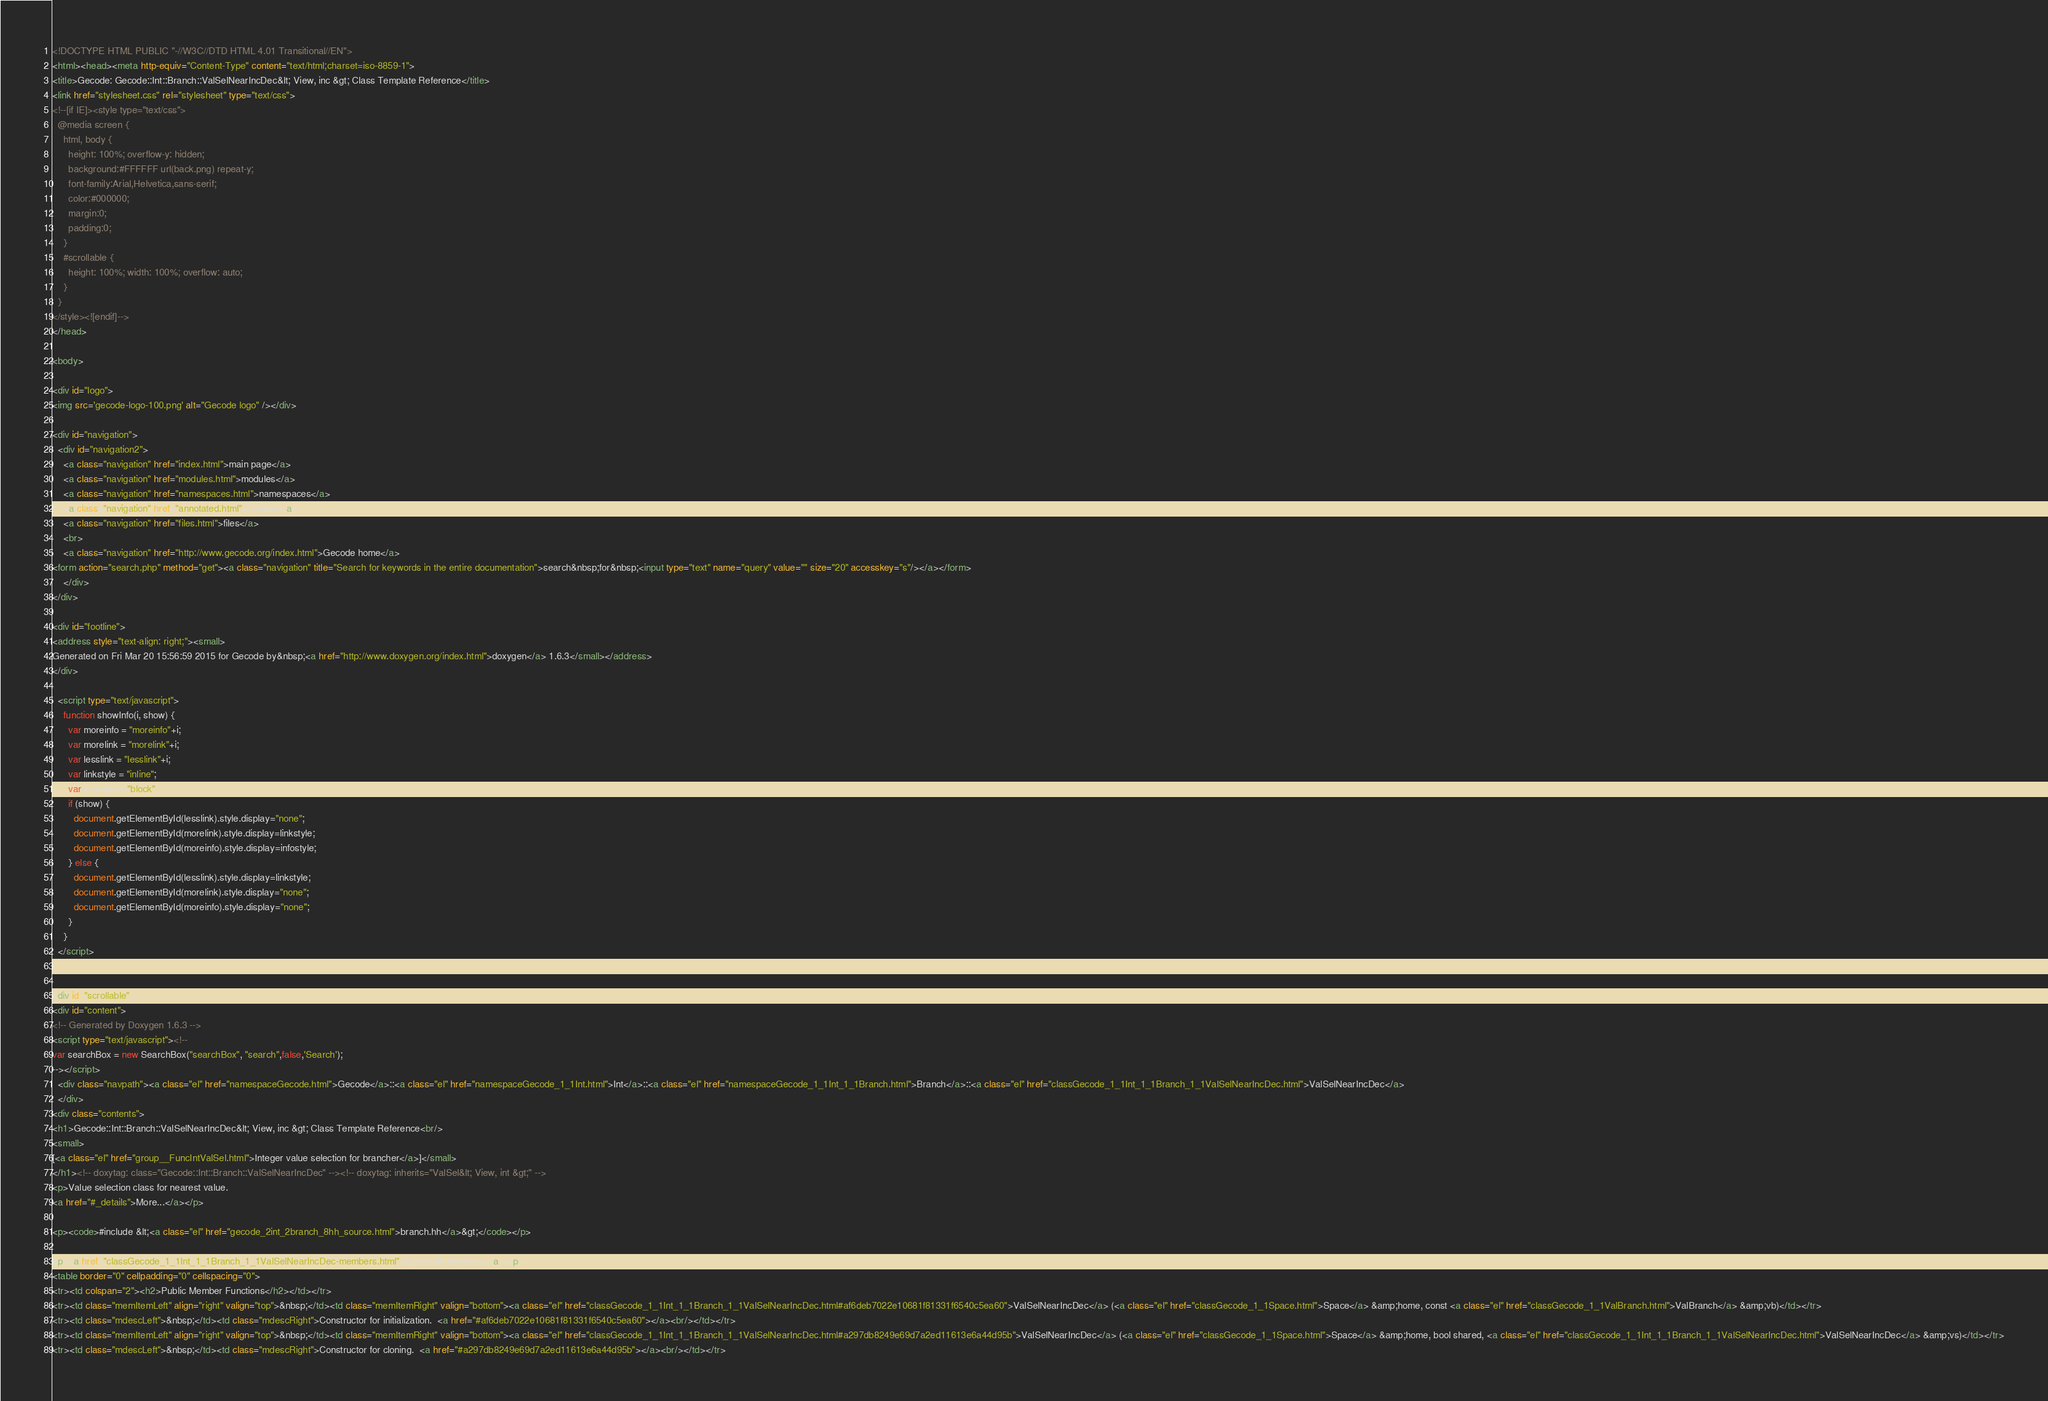Convert code to text. <code><loc_0><loc_0><loc_500><loc_500><_HTML_><!DOCTYPE HTML PUBLIC "-//W3C//DTD HTML 4.01 Transitional//EN">
<html><head><meta http-equiv="Content-Type" content="text/html;charset=iso-8859-1">
<title>Gecode: Gecode::Int::Branch::ValSelNearIncDec&lt; View, inc &gt; Class Template Reference</title>
<link href="stylesheet.css" rel="stylesheet" type="text/css">
<!--[if IE]><style type="text/css">
  @media screen {
    html, body {
      height: 100%; overflow-y: hidden;
      background:#FFFFFF url(back.png) repeat-y;
      font-family:Arial,Helvetica,sans-serif;
      color:#000000;
      margin:0;
      padding:0;
    }
    #scrollable {
      height: 100%; width: 100%; overflow: auto;
    }
  }
</style><![endif]-->
</head>

<body>

<div id="logo">
<img src='gecode-logo-100.png' alt="Gecode logo" /></div>

<div id="navigation">
  <div id="navigation2">
    <a class="navigation" href="index.html">main page</a>
    <a class="navigation" href="modules.html">modules</a>
    <a class="navigation" href="namespaces.html">namespaces</a>
    <a class="navigation" href="annotated.html">classes</a>
    <a class="navigation" href="files.html">files</a>
    <br>
    <a class="navigation" href="http://www.gecode.org/index.html">Gecode home</a>
<form action="search.php" method="get"><a class="navigation" title="Search for keywords in the entire documentation">search&nbsp;for&nbsp;<input type="text" name="query" value="" size="20" accesskey="s"/></a></form>
    </div>
</div>

<div id="footline">
<address style="text-align: right;"><small>
Generated on Fri Mar 20 15:56:59 2015 for Gecode by&nbsp;<a href="http://www.doxygen.org/index.html">doxygen</a> 1.6.3</small></address>
</div>

  <script type="text/javascript">
    function showInfo(i, show) {
      var moreinfo = "moreinfo"+i;
      var morelink = "morelink"+i;
      var lesslink = "lesslink"+i;
      var linkstyle = "inline";
      var infostyle = "block";
      if (show) {
        document.getElementById(lesslink).style.display="none";
        document.getElementById(morelink).style.display=linkstyle;
        document.getElementById(moreinfo).style.display=infostyle;
      } else {
        document.getElementById(lesslink).style.display=linkstyle;        
        document.getElementById(morelink).style.display="none";        
        document.getElementById(moreinfo).style.display="none";        
      }
    }
  </script>


<div id="scrollable">
<div id="content">
<!-- Generated by Doxygen 1.6.3 -->
<script type="text/javascript"><!--
var searchBox = new SearchBox("searchBox", "search",false,'Search');
--></script>
  <div class="navpath"><a class="el" href="namespaceGecode.html">Gecode</a>::<a class="el" href="namespaceGecode_1_1Int.html">Int</a>::<a class="el" href="namespaceGecode_1_1Int_1_1Branch.html">Branch</a>::<a class="el" href="classGecode_1_1Int_1_1Branch_1_1ValSelNearIncDec.html">ValSelNearIncDec</a>
  </div>
<div class="contents">
<h1>Gecode::Int::Branch::ValSelNearIncDec&lt; View, inc &gt; Class Template Reference<br/>
<small>
[<a class="el" href="group__FuncIntValSel.html">Integer value selection for brancher</a>]</small>
</h1><!-- doxytag: class="Gecode::Int::Branch::ValSelNearIncDec" --><!-- doxytag: inherits="ValSel&lt; View, int &gt;" -->
<p>Value selection class for nearest value.  
<a href="#_details">More...</a></p>

<p><code>#include &lt;<a class="el" href="gecode_2int_2branch_8hh_source.html">branch.hh</a>&gt;</code></p>

<p><a href="classGecode_1_1Int_1_1Branch_1_1ValSelNearIncDec-members.html">List of all members.</a></p>
<table border="0" cellpadding="0" cellspacing="0">
<tr><td colspan="2"><h2>Public Member Functions</h2></td></tr>
<tr><td class="memItemLeft" align="right" valign="top">&nbsp;</td><td class="memItemRight" valign="bottom"><a class="el" href="classGecode_1_1Int_1_1Branch_1_1ValSelNearIncDec.html#af6deb7022e10681f81331f6540c5ea60">ValSelNearIncDec</a> (<a class="el" href="classGecode_1_1Space.html">Space</a> &amp;home, const <a class="el" href="classGecode_1_1ValBranch.html">ValBranch</a> &amp;vb)</td></tr>
<tr><td class="mdescLeft">&nbsp;</td><td class="mdescRight">Constructor for initialization.  <a href="#af6deb7022e10681f81331f6540c5ea60"></a><br/></td></tr>
<tr><td class="memItemLeft" align="right" valign="top">&nbsp;</td><td class="memItemRight" valign="bottom"><a class="el" href="classGecode_1_1Int_1_1Branch_1_1ValSelNearIncDec.html#a297db8249e69d7a2ed11613e6a44d95b">ValSelNearIncDec</a> (<a class="el" href="classGecode_1_1Space.html">Space</a> &amp;home, bool shared, <a class="el" href="classGecode_1_1Int_1_1Branch_1_1ValSelNearIncDec.html">ValSelNearIncDec</a> &amp;vs)</td></tr>
<tr><td class="mdescLeft">&nbsp;</td><td class="mdescRight">Constructor for cloning.  <a href="#a297db8249e69d7a2ed11613e6a44d95b"></a><br/></td></tr></code> 